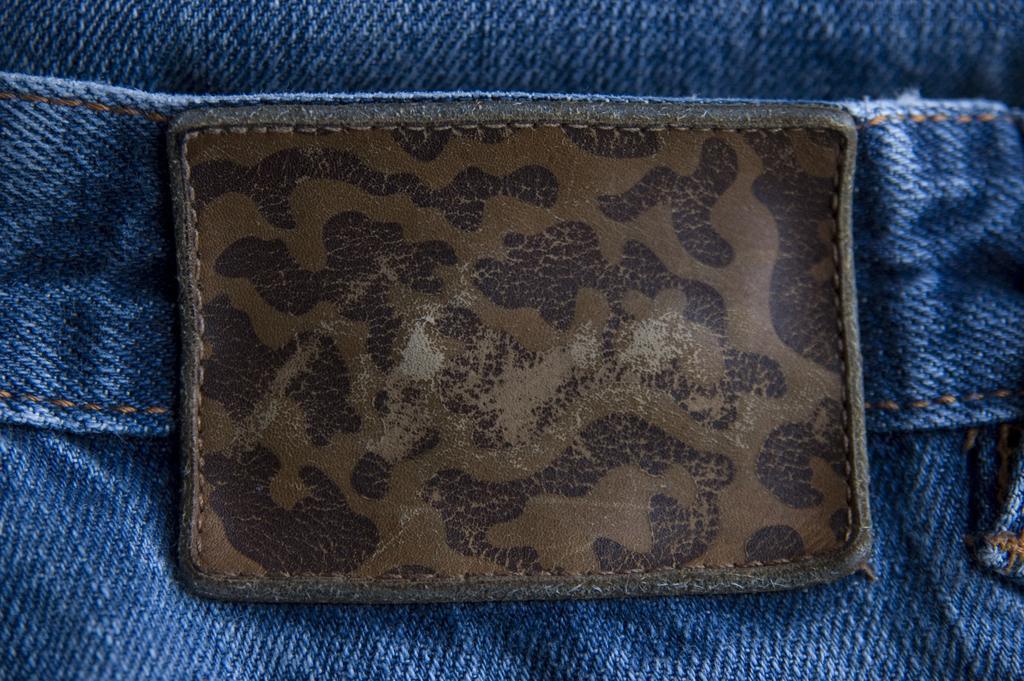Please provide a concise description of this image. In this image I can see a leather piece on a jeans pant. 